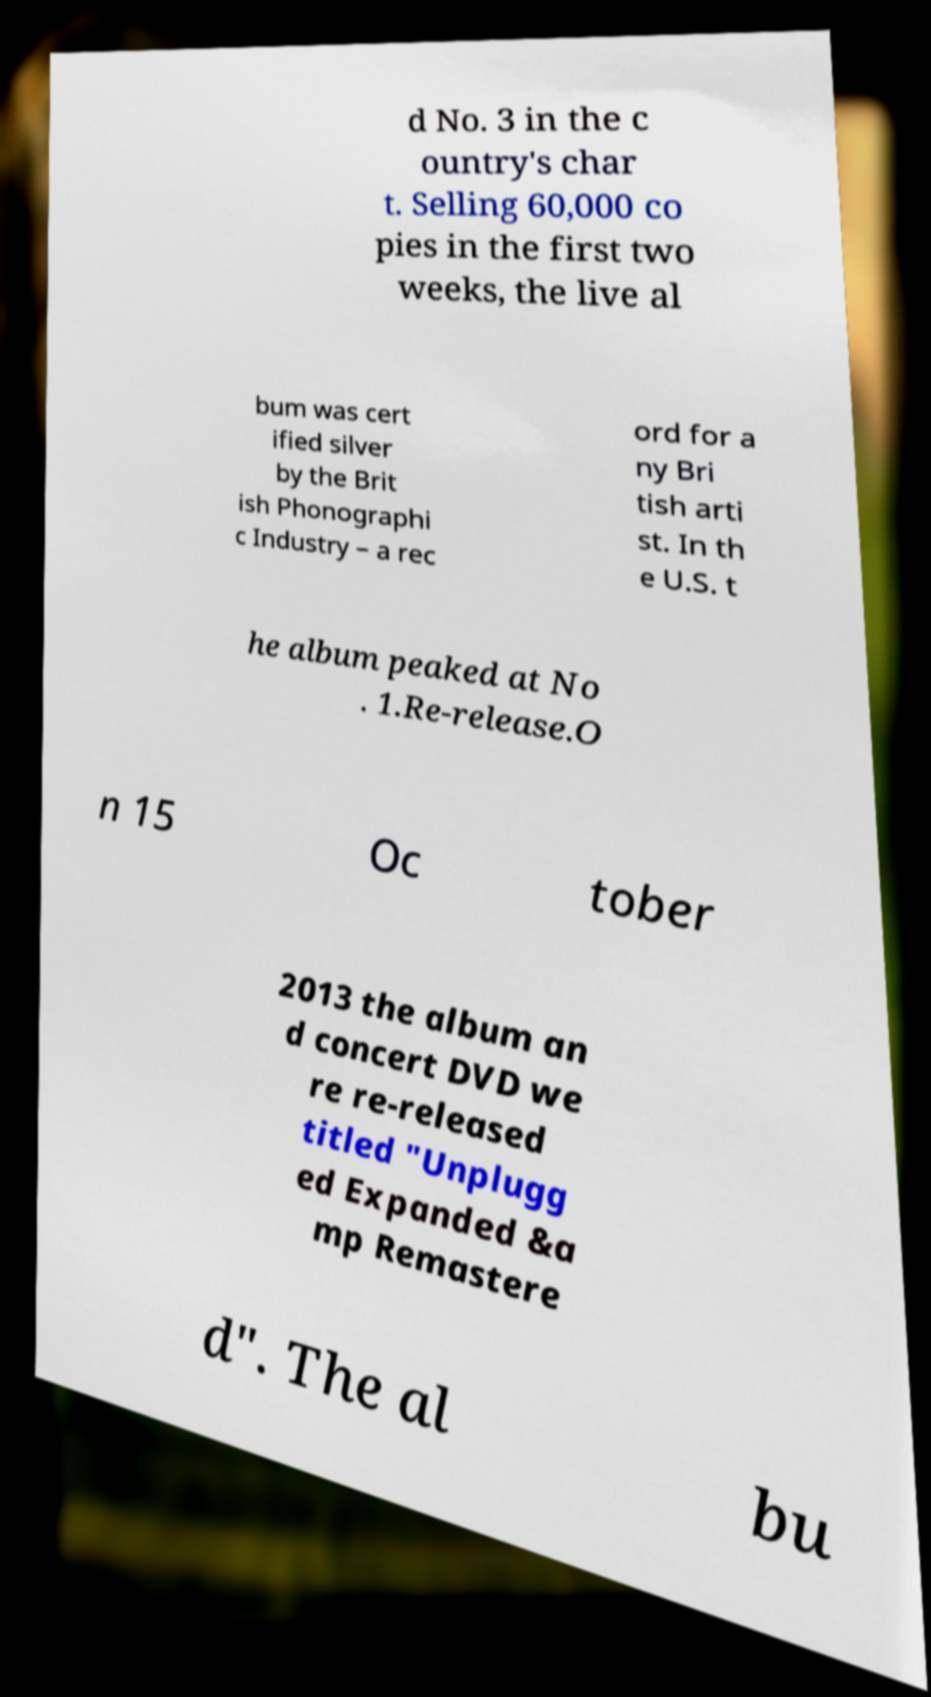For documentation purposes, I need the text within this image transcribed. Could you provide that? d No. 3 in the c ountry's char t. Selling 60,000 co pies in the first two weeks, the live al bum was cert ified silver by the Brit ish Phonographi c Industry – a rec ord for a ny Bri tish arti st. In th e U.S. t he album peaked at No . 1.Re-release.O n 15 Oc tober 2013 the album an d concert DVD we re re-released titled "Unplugg ed Expanded &a mp Remastere d". The al bu 